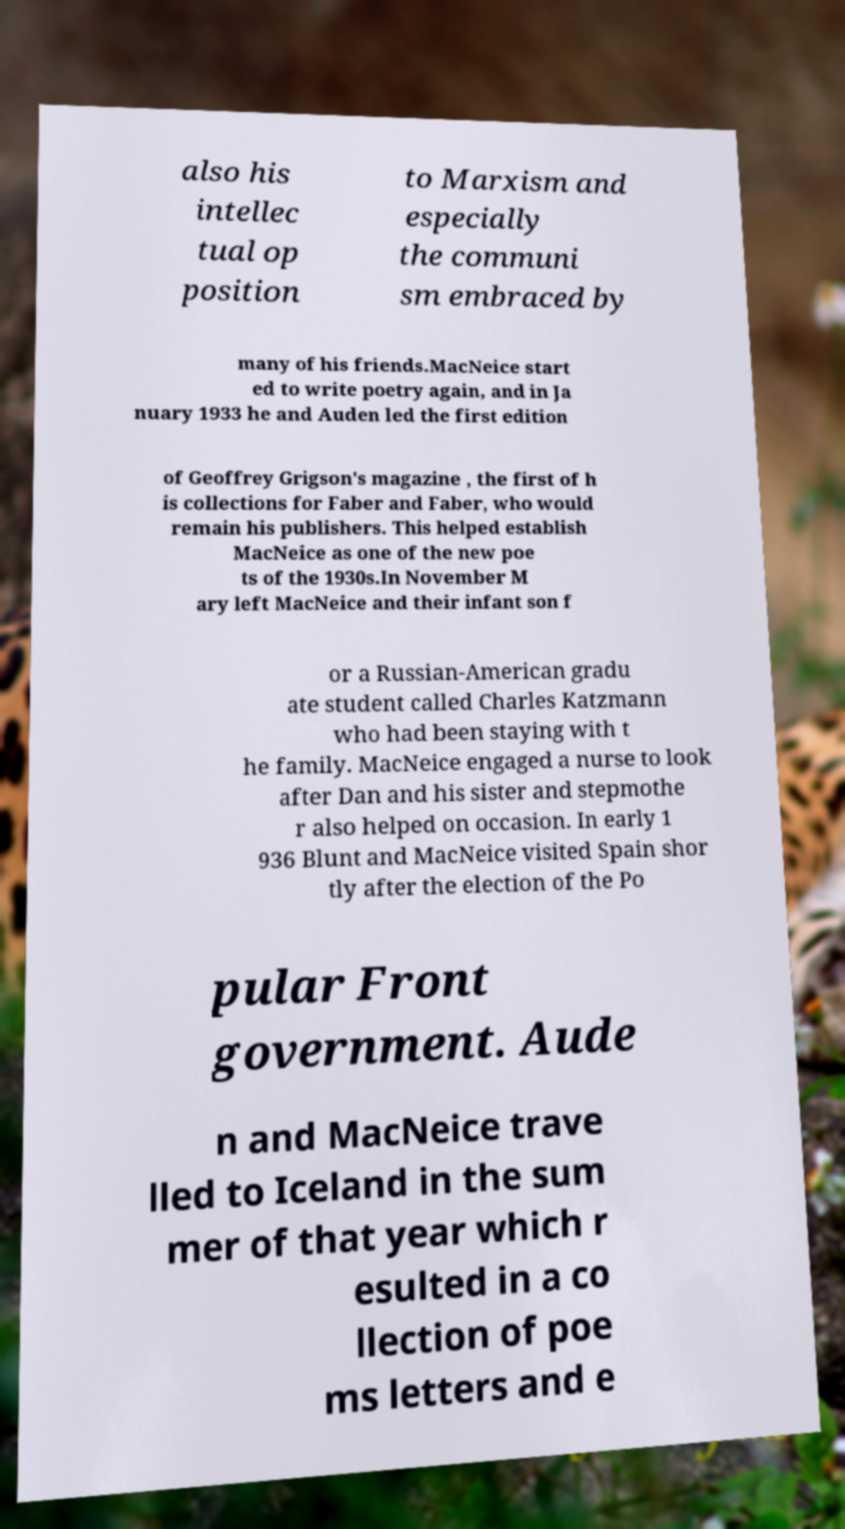Can you accurately transcribe the text from the provided image for me? also his intellec tual op position to Marxism and especially the communi sm embraced by many of his friends.MacNeice start ed to write poetry again, and in Ja nuary 1933 he and Auden led the first edition of Geoffrey Grigson's magazine , the first of h is collections for Faber and Faber, who would remain his publishers. This helped establish MacNeice as one of the new poe ts of the 1930s.In November M ary left MacNeice and their infant son f or a Russian-American gradu ate student called Charles Katzmann who had been staying with t he family. MacNeice engaged a nurse to look after Dan and his sister and stepmothe r also helped on occasion. In early 1 936 Blunt and MacNeice visited Spain shor tly after the election of the Po pular Front government. Aude n and MacNeice trave lled to Iceland in the sum mer of that year which r esulted in a co llection of poe ms letters and e 